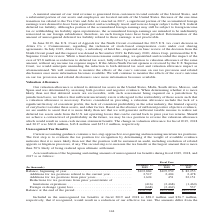According to Sunpower Corporation's financial document, What would be the result if unrecognized tax benefits in 2019 and 2018 become recognized? Would result in a reduction of our effective tax rate. The document states: "$36.7 million, respectively, that if recognized, would result in a reduction of our effective tax rate. The amounts differ from the..." Also, What events would cause a change in unrecognized tax benefits? The document shows two values: Commencement, continuation or completion of examinations of our tax returns by the U.S. or foreign taxing authorities and expiration of statutes of limitation on our tax returns. Also, What is the Balance, beginning of year for 2019? According to the financial document, 103,884 (in thousands). The relevant text states: "December 31, 2017 Balance, beginning of year. . $103,884 $105,959 $ 82,253 Additions for tax positions related to the current year . 2,517 2,404 2,478 Addit..." Additionally, Which year was the balance in the beginning of the year the highest? According to the financial document, 2018. The relevant text states: "(In thousands) December 29, 2019 December 30, 2018 December 31, 2017 Balance, beginning of year. . $103,884 $105,959 $ 82,253 Additions for tax positi..." Also, can you calculate: What was the change in long term liability from 2018 to 2019? Based on the calculation: 20.1 million - 16.8 million , the result is 3.3 (in millions). The key data points involved are: 16.8, 20.1. Also, can you calculate: What was the percentage change of the balance at the end of the period from 2018 to 2019? To answer this question, I need to perform calculations using the financial data. The calculation is: ($106,941 - $103,884)/$103,884 , which equals 2.94 (percentage). This is based on the information: ") (2,462) 537 Balance at the end of the period . $106,941 $103,884 $105,959 December 31, 2017 Balance, beginning of year. . $103,884 $105,959 $ 82,253 Additions for tax positions related to the curren..." The key data points involved are: 103,884, 106,941. 